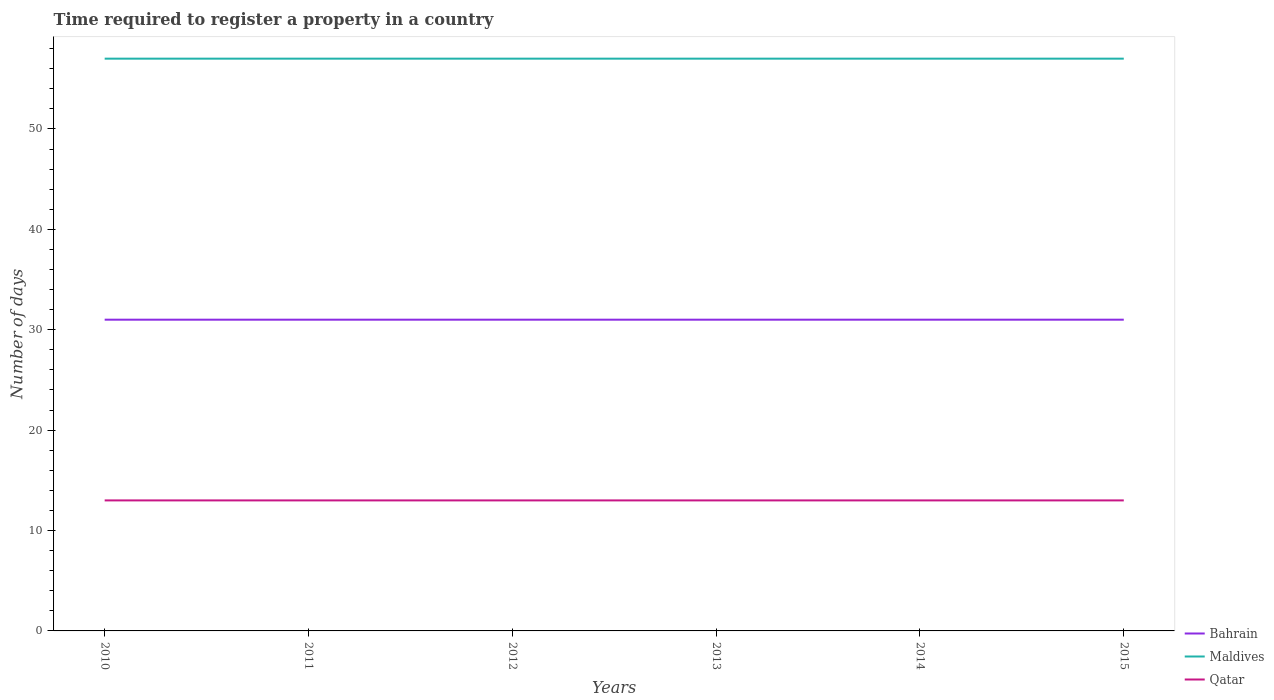How many different coloured lines are there?
Give a very brief answer. 3. Does the line corresponding to Bahrain intersect with the line corresponding to Qatar?
Provide a short and direct response. No. Is the number of lines equal to the number of legend labels?
Keep it short and to the point. Yes. In which year was the number of days required to register a property in Qatar maximum?
Give a very brief answer. 2010. What is the total number of days required to register a property in Qatar in the graph?
Ensure brevity in your answer.  0. What is the difference between the highest and the second highest number of days required to register a property in Qatar?
Your response must be concise. 0. What is the difference between the highest and the lowest number of days required to register a property in Bahrain?
Provide a short and direct response. 0. Is the number of days required to register a property in Qatar strictly greater than the number of days required to register a property in Bahrain over the years?
Ensure brevity in your answer.  Yes. How many lines are there?
Give a very brief answer. 3. How many years are there in the graph?
Offer a terse response. 6. What is the difference between two consecutive major ticks on the Y-axis?
Give a very brief answer. 10. Are the values on the major ticks of Y-axis written in scientific E-notation?
Provide a short and direct response. No. Does the graph contain any zero values?
Keep it short and to the point. No. Does the graph contain grids?
Offer a very short reply. No. How many legend labels are there?
Your response must be concise. 3. How are the legend labels stacked?
Make the answer very short. Vertical. What is the title of the graph?
Offer a terse response. Time required to register a property in a country. Does "Myanmar" appear as one of the legend labels in the graph?
Provide a short and direct response. No. What is the label or title of the X-axis?
Your answer should be compact. Years. What is the label or title of the Y-axis?
Offer a terse response. Number of days. What is the Number of days in Maldives in 2010?
Your answer should be compact. 57. What is the Number of days of Qatar in 2011?
Make the answer very short. 13. What is the Number of days in Maldives in 2012?
Provide a succinct answer. 57. What is the Number of days of Qatar in 2013?
Offer a terse response. 13. What is the Number of days in Bahrain in 2014?
Offer a very short reply. 31. What is the Number of days of Maldives in 2014?
Provide a succinct answer. 57. What is the Number of days of Qatar in 2014?
Keep it short and to the point. 13. Across all years, what is the maximum Number of days in Bahrain?
Make the answer very short. 31. Across all years, what is the maximum Number of days of Maldives?
Provide a short and direct response. 57. Across all years, what is the maximum Number of days of Qatar?
Make the answer very short. 13. Across all years, what is the minimum Number of days in Bahrain?
Provide a short and direct response. 31. What is the total Number of days in Bahrain in the graph?
Your response must be concise. 186. What is the total Number of days in Maldives in the graph?
Offer a terse response. 342. What is the total Number of days in Qatar in the graph?
Your answer should be compact. 78. What is the difference between the Number of days of Bahrain in 2010 and that in 2011?
Your response must be concise. 0. What is the difference between the Number of days in Maldives in 2010 and that in 2011?
Provide a short and direct response. 0. What is the difference between the Number of days in Qatar in 2010 and that in 2011?
Make the answer very short. 0. What is the difference between the Number of days in Qatar in 2010 and that in 2012?
Offer a terse response. 0. What is the difference between the Number of days of Maldives in 2010 and that in 2013?
Your answer should be very brief. 0. What is the difference between the Number of days of Qatar in 2010 and that in 2013?
Offer a very short reply. 0. What is the difference between the Number of days of Bahrain in 2010 and that in 2014?
Make the answer very short. 0. What is the difference between the Number of days in Maldives in 2010 and that in 2014?
Your response must be concise. 0. What is the difference between the Number of days in Maldives in 2010 and that in 2015?
Make the answer very short. 0. What is the difference between the Number of days of Bahrain in 2011 and that in 2012?
Ensure brevity in your answer.  0. What is the difference between the Number of days in Maldives in 2011 and that in 2012?
Offer a very short reply. 0. What is the difference between the Number of days of Qatar in 2011 and that in 2012?
Your answer should be very brief. 0. What is the difference between the Number of days of Maldives in 2011 and that in 2013?
Ensure brevity in your answer.  0. What is the difference between the Number of days of Qatar in 2011 and that in 2013?
Your response must be concise. 0. What is the difference between the Number of days in Qatar in 2011 and that in 2014?
Your answer should be very brief. 0. What is the difference between the Number of days in Maldives in 2012 and that in 2013?
Provide a succinct answer. 0. What is the difference between the Number of days in Bahrain in 2012 and that in 2014?
Offer a terse response. 0. What is the difference between the Number of days of Bahrain in 2012 and that in 2015?
Your answer should be very brief. 0. What is the difference between the Number of days of Maldives in 2012 and that in 2015?
Offer a very short reply. 0. What is the difference between the Number of days of Qatar in 2012 and that in 2015?
Ensure brevity in your answer.  0. What is the difference between the Number of days of Maldives in 2013 and that in 2014?
Keep it short and to the point. 0. What is the difference between the Number of days of Qatar in 2013 and that in 2015?
Make the answer very short. 0. What is the difference between the Number of days in Qatar in 2014 and that in 2015?
Provide a short and direct response. 0. What is the difference between the Number of days of Maldives in 2010 and the Number of days of Qatar in 2011?
Offer a very short reply. 44. What is the difference between the Number of days of Bahrain in 2010 and the Number of days of Qatar in 2012?
Give a very brief answer. 18. What is the difference between the Number of days of Maldives in 2010 and the Number of days of Qatar in 2012?
Your response must be concise. 44. What is the difference between the Number of days of Maldives in 2010 and the Number of days of Qatar in 2014?
Offer a very short reply. 44. What is the difference between the Number of days of Maldives in 2011 and the Number of days of Qatar in 2012?
Provide a short and direct response. 44. What is the difference between the Number of days of Bahrain in 2011 and the Number of days of Qatar in 2013?
Your response must be concise. 18. What is the difference between the Number of days of Bahrain in 2011 and the Number of days of Qatar in 2014?
Keep it short and to the point. 18. What is the difference between the Number of days of Maldives in 2011 and the Number of days of Qatar in 2015?
Keep it short and to the point. 44. What is the difference between the Number of days in Maldives in 2012 and the Number of days in Qatar in 2013?
Give a very brief answer. 44. What is the difference between the Number of days of Bahrain in 2012 and the Number of days of Qatar in 2014?
Ensure brevity in your answer.  18. What is the difference between the Number of days in Maldives in 2012 and the Number of days in Qatar in 2015?
Keep it short and to the point. 44. What is the difference between the Number of days of Bahrain in 2013 and the Number of days of Maldives in 2014?
Provide a succinct answer. -26. What is the difference between the Number of days of Bahrain in 2013 and the Number of days of Maldives in 2015?
Provide a short and direct response. -26. What is the difference between the Number of days in Maldives in 2013 and the Number of days in Qatar in 2015?
Offer a very short reply. 44. What is the difference between the Number of days of Bahrain in 2014 and the Number of days of Qatar in 2015?
Offer a very short reply. 18. What is the difference between the Number of days in Maldives in 2014 and the Number of days in Qatar in 2015?
Give a very brief answer. 44. What is the average Number of days of Maldives per year?
Your response must be concise. 57. What is the average Number of days of Qatar per year?
Make the answer very short. 13. In the year 2010, what is the difference between the Number of days in Bahrain and Number of days in Maldives?
Give a very brief answer. -26. In the year 2010, what is the difference between the Number of days of Bahrain and Number of days of Qatar?
Your answer should be very brief. 18. In the year 2010, what is the difference between the Number of days of Maldives and Number of days of Qatar?
Provide a succinct answer. 44. In the year 2011, what is the difference between the Number of days in Bahrain and Number of days in Maldives?
Give a very brief answer. -26. In the year 2011, what is the difference between the Number of days of Bahrain and Number of days of Qatar?
Your response must be concise. 18. In the year 2012, what is the difference between the Number of days in Bahrain and Number of days in Maldives?
Your answer should be compact. -26. In the year 2012, what is the difference between the Number of days of Maldives and Number of days of Qatar?
Keep it short and to the point. 44. In the year 2013, what is the difference between the Number of days of Bahrain and Number of days of Maldives?
Keep it short and to the point. -26. In the year 2014, what is the difference between the Number of days of Bahrain and Number of days of Maldives?
Give a very brief answer. -26. In the year 2014, what is the difference between the Number of days in Bahrain and Number of days in Qatar?
Make the answer very short. 18. In the year 2014, what is the difference between the Number of days of Maldives and Number of days of Qatar?
Provide a succinct answer. 44. In the year 2015, what is the difference between the Number of days in Bahrain and Number of days in Qatar?
Offer a terse response. 18. What is the ratio of the Number of days in Maldives in 2010 to that in 2011?
Your answer should be very brief. 1. What is the ratio of the Number of days of Qatar in 2010 to that in 2012?
Ensure brevity in your answer.  1. What is the ratio of the Number of days in Bahrain in 2010 to that in 2013?
Make the answer very short. 1. What is the ratio of the Number of days in Maldives in 2010 to that in 2013?
Your response must be concise. 1. What is the ratio of the Number of days of Qatar in 2010 to that in 2013?
Offer a terse response. 1. What is the ratio of the Number of days of Qatar in 2010 to that in 2015?
Make the answer very short. 1. What is the ratio of the Number of days of Maldives in 2011 to that in 2012?
Make the answer very short. 1. What is the ratio of the Number of days in Qatar in 2011 to that in 2012?
Your answer should be compact. 1. What is the ratio of the Number of days in Maldives in 2011 to that in 2013?
Provide a succinct answer. 1. What is the ratio of the Number of days of Qatar in 2011 to that in 2013?
Make the answer very short. 1. What is the ratio of the Number of days in Maldives in 2011 to that in 2015?
Your response must be concise. 1. What is the ratio of the Number of days of Qatar in 2011 to that in 2015?
Your response must be concise. 1. What is the ratio of the Number of days of Bahrain in 2012 to that in 2013?
Provide a short and direct response. 1. What is the ratio of the Number of days in Maldives in 2012 to that in 2013?
Your answer should be compact. 1. What is the ratio of the Number of days of Qatar in 2012 to that in 2013?
Offer a terse response. 1. What is the ratio of the Number of days of Qatar in 2012 to that in 2014?
Your response must be concise. 1. What is the ratio of the Number of days in Bahrain in 2012 to that in 2015?
Provide a succinct answer. 1. What is the ratio of the Number of days of Qatar in 2012 to that in 2015?
Provide a short and direct response. 1. What is the ratio of the Number of days in Bahrain in 2013 to that in 2014?
Keep it short and to the point. 1. What is the ratio of the Number of days in Maldives in 2013 to that in 2014?
Offer a terse response. 1. What is the ratio of the Number of days in Qatar in 2013 to that in 2014?
Offer a very short reply. 1. What is the ratio of the Number of days in Qatar in 2013 to that in 2015?
Keep it short and to the point. 1. What is the ratio of the Number of days in Qatar in 2014 to that in 2015?
Your answer should be compact. 1. What is the difference between the highest and the second highest Number of days in Maldives?
Keep it short and to the point. 0. What is the difference between the highest and the second highest Number of days of Qatar?
Your response must be concise. 0. 